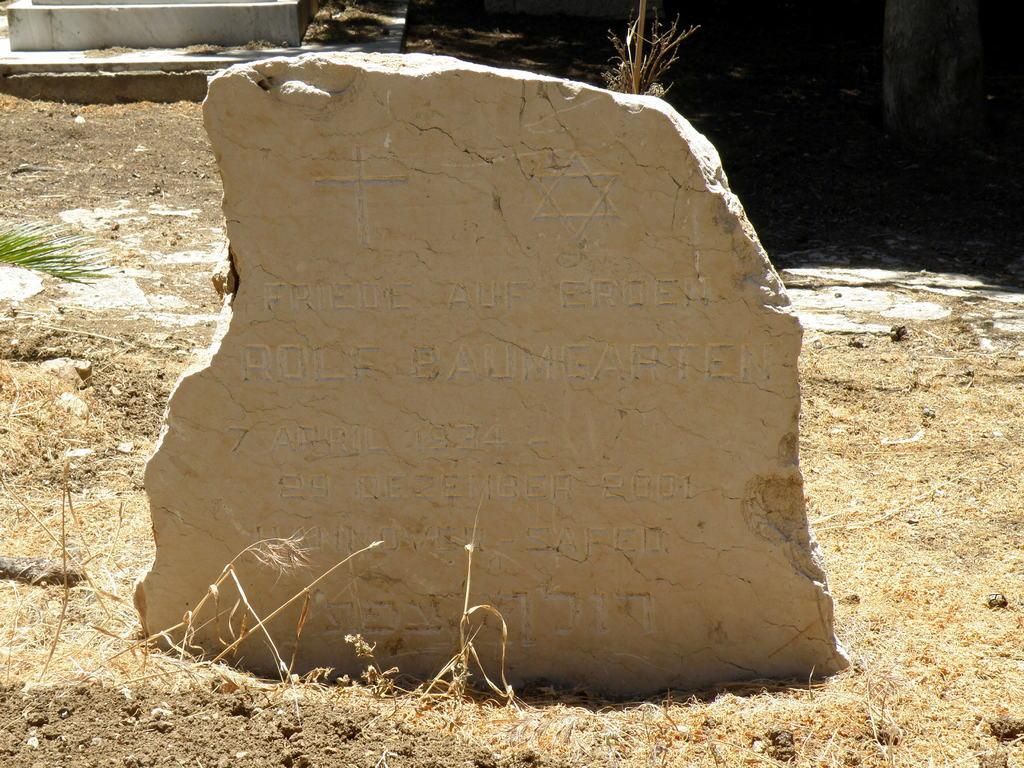What is the main object in the front of the image? There is a stone with text in the front of the image. What type of vegetation can be seen in the background of the image? There is grass in the background of the image. What structures are visible in the background of the image? There is a wall and a marble stone in the background of the image. How many clocks are hanging on the wall in the image? There are no clocks visible in the image. What type of question is being asked on the stone in the image? The stone in the image has text, but it is not a question. 